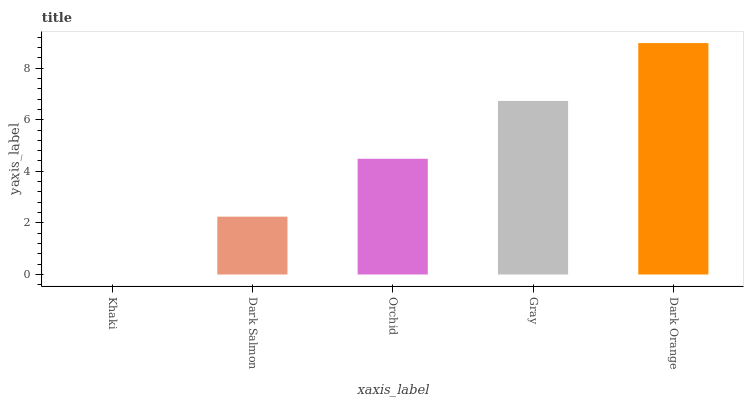Is Khaki the minimum?
Answer yes or no. Yes. Is Dark Orange the maximum?
Answer yes or no. Yes. Is Dark Salmon the minimum?
Answer yes or no. No. Is Dark Salmon the maximum?
Answer yes or no. No. Is Dark Salmon greater than Khaki?
Answer yes or no. Yes. Is Khaki less than Dark Salmon?
Answer yes or no. Yes. Is Khaki greater than Dark Salmon?
Answer yes or no. No. Is Dark Salmon less than Khaki?
Answer yes or no. No. Is Orchid the high median?
Answer yes or no. Yes. Is Orchid the low median?
Answer yes or no. Yes. Is Dark Orange the high median?
Answer yes or no. No. Is Dark Salmon the low median?
Answer yes or no. No. 